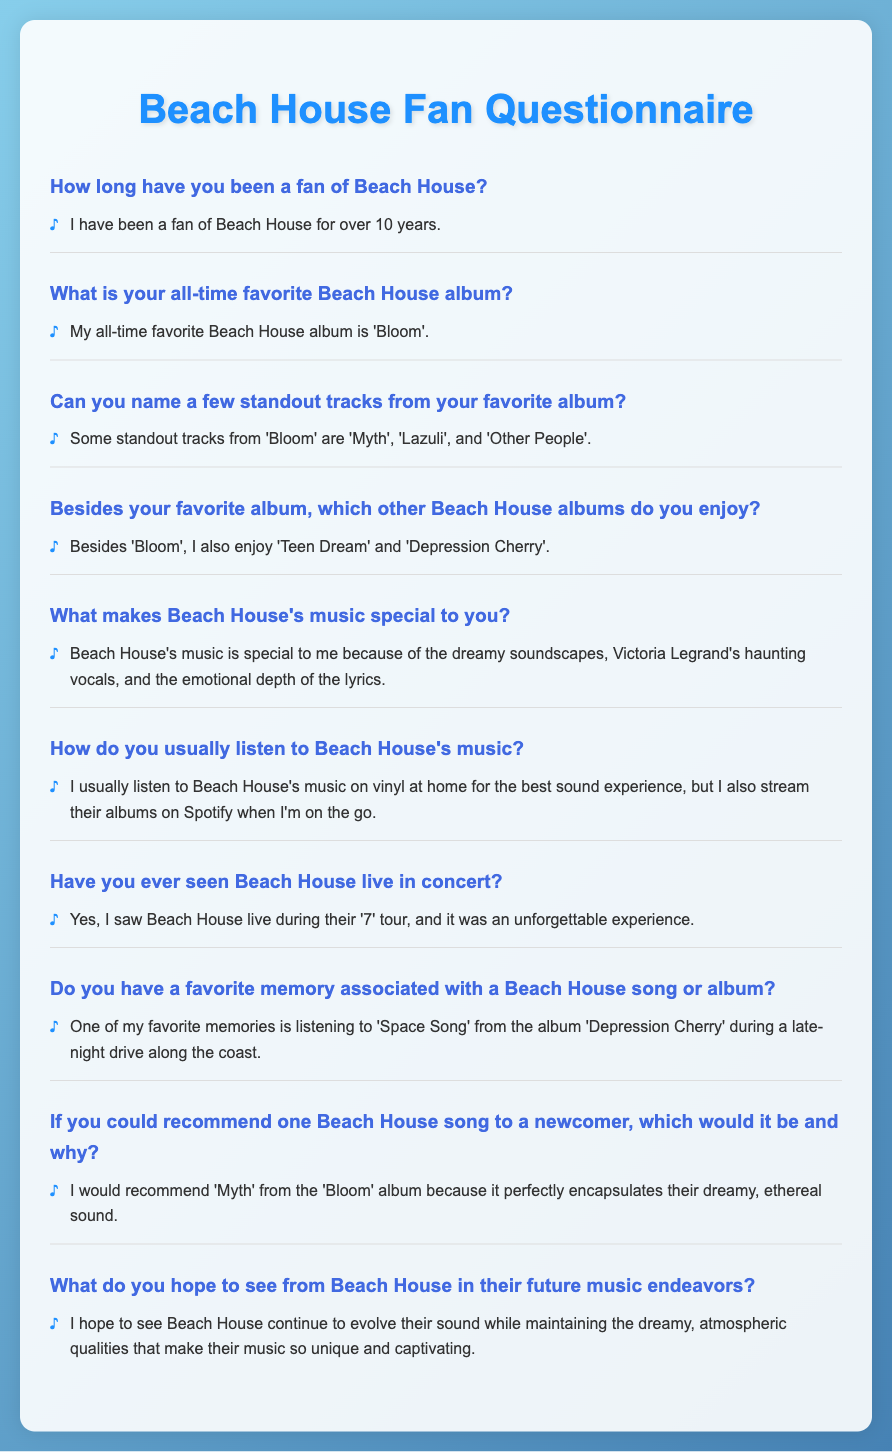How long has the fan been a Beach House fan? The fan has mentioned they have been a fan for over 10 years.
Answer: Over 10 years What is the fan's all-time favorite Beach House album? The fan stated their all-time favorite album is 'Bloom'.
Answer: 'Bloom' Which standout track from 'Bloom' is mentioned first? The fan listed 'Myth' as the first standout track from 'Bloom'.
Answer: 'Myth' Besides 'Bloom', which other two albums does the fan enjoy? The fan mentioned enjoying 'Teen Dream' and 'Depression Cherry' in addition to 'Bloom'.
Answer: 'Teen Dream' and 'Depression Cherry' What is special about Beach House's music to the fan? The fan noted the dreamy soundscapes, haunting vocals, and emotional depth of the lyrics.
Answer: Dreamy soundscapes, haunting vocals, and emotional depth Where does the fan usually listen to Beach House's music? The fan typically listens to Beach House's music on vinyl at home and streams on Spotify when out.
Answer: On vinyl at home and on Spotify What memory does the fan associate with a Beach House song? The fan recalls listening to 'Space Song' during a late-night drive along the coast.
Answer: Late-night drive along the coast Which Beach House song does the fan recommend to newcomers? The recommended song is 'Myth' from the 'Bloom' album due to its dreamy sound.
Answer: 'Myth' What does the fan hope for Beach House's future music? The fan hopes to see Beach House evolve their sound while keeping their unique qualities.
Answer: Evolve their sound while maintaining unique qualities 